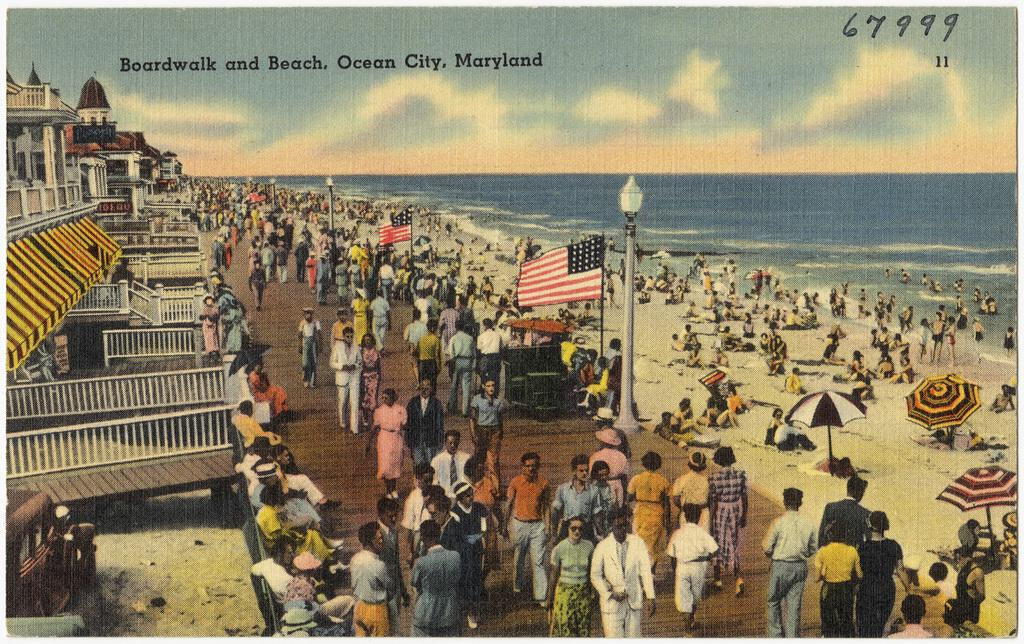Provide a one-sentence caption for the provided image. an old postcard with Boardwalk and Beach, Ocean City, Maryland on it. 